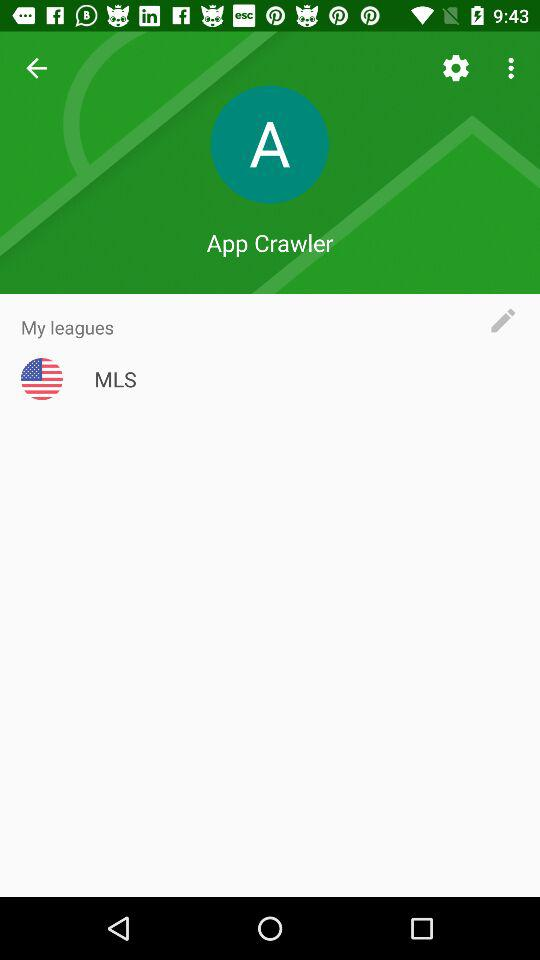What is the user name? The user name is App Crawler. 